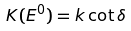Convert formula to latex. <formula><loc_0><loc_0><loc_500><loc_500>K ( E ^ { 0 } ) = k \cot \delta</formula> 